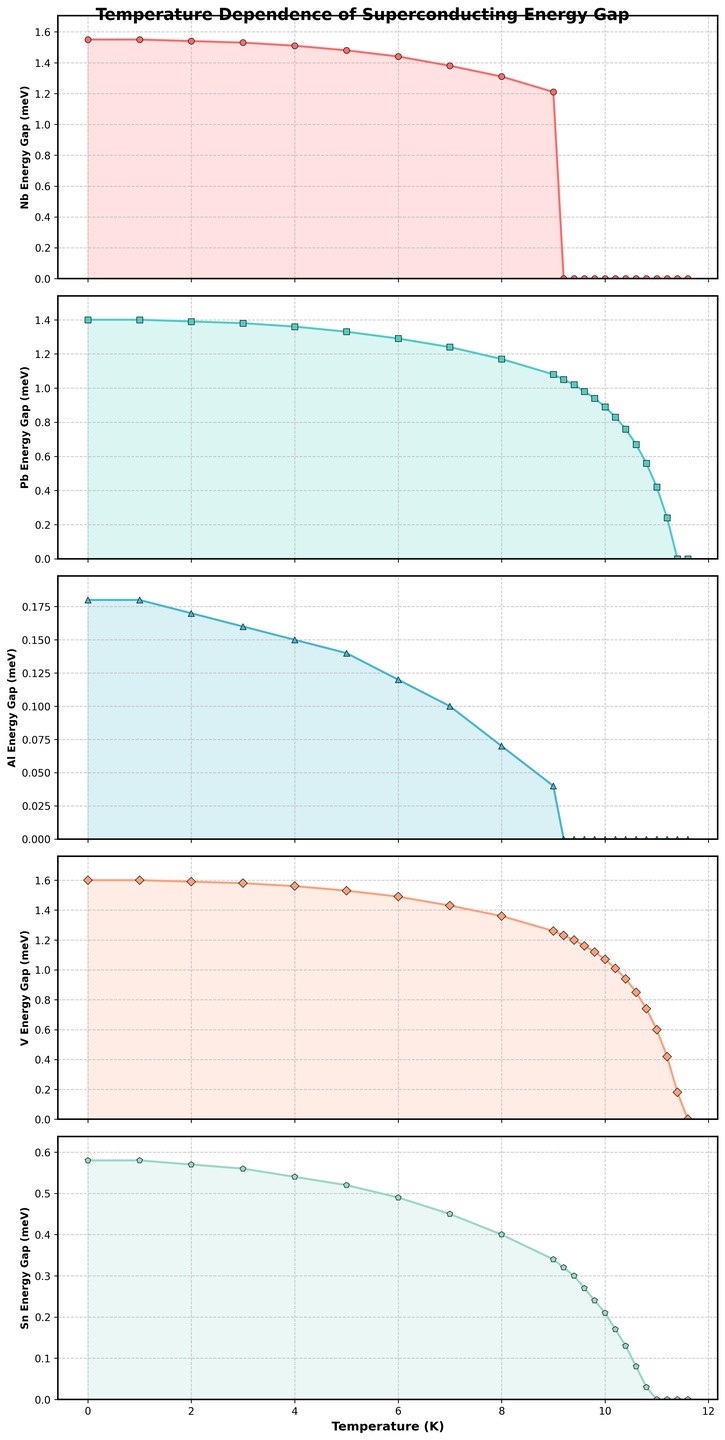What is the energy gap of Niobium (Nb) at 5 K? According to the plot for Niobium, the energy gap at 5 K, which can be identified by looking at the horizontal axis at 5 K and then tracking up to the curve, is around 1.48 meV.
Answer: 1.48 meV For which temperature does the energy gap of Tin (Sn) become zero? From the plot of Tin, the energy gap gradually decreases and eventually becomes zero at around 11 K. This can be observed where the curve intersects the horizontal axis of the plot.
Answer: 11 K How does the energy gap of Lead (Pb) at 6 K compare to that of Aluminum (Al) at the same temperature? At 6 K, the energy gap for Lead (Pb) is around 1.29 meV, and for Aluminum (Al), it is approximately 0.12 meV. By comparing these values, Lead has a higher energy gap than Aluminum at this temperature.
Answer: Lead has a higher energy gap than Aluminum At which temperature does the energy gap of Vanadium (V) start to significantly drop? Observing the plot for Vanadium, it appears that the energy gap starts to drop significantly around 8 K, as the curve becomes steeper beyond this point.
Answer: 8 K What is the difference in energy gap between Lead (Pb) and Tin (Sn) at 9.8 K? At 9.8 K, the energy gap of Lead (Pb) is approximately 0.94 meV, and for Tin (Sn), it is around 0.24 meV. The difference is 0.94 - 0.24 = 0.70 meV.
Answer: 0.70 meV Which material has the highest energy gap at 0 K? At 0 K, Niobium (Nb) has the highest energy gap among the materials listed, with a value of around 1.55 meV. This is observed by comparing the starting points of each curve at 0 K.
Answer: Niobium (Nb) By how much does the energy gap of Vanadium (V) decrease from 0 K to 10 K? At 0 K, the energy gap for Vanadium is approximately 1.60 meV, and at 10 K it is around 1.07 meV. The decrease is therefore 1.60 - 1.07 = 0.53 meV.
Answer: 0.53 meV What temperature range shows the largest drop in energy gap for Aluminum (Al)? In the Aluminum (Al) plot, the most significant drop happens between 8 K and 9.2 K, where the curve is steep.
Answer: 8 K to 9.2 K 